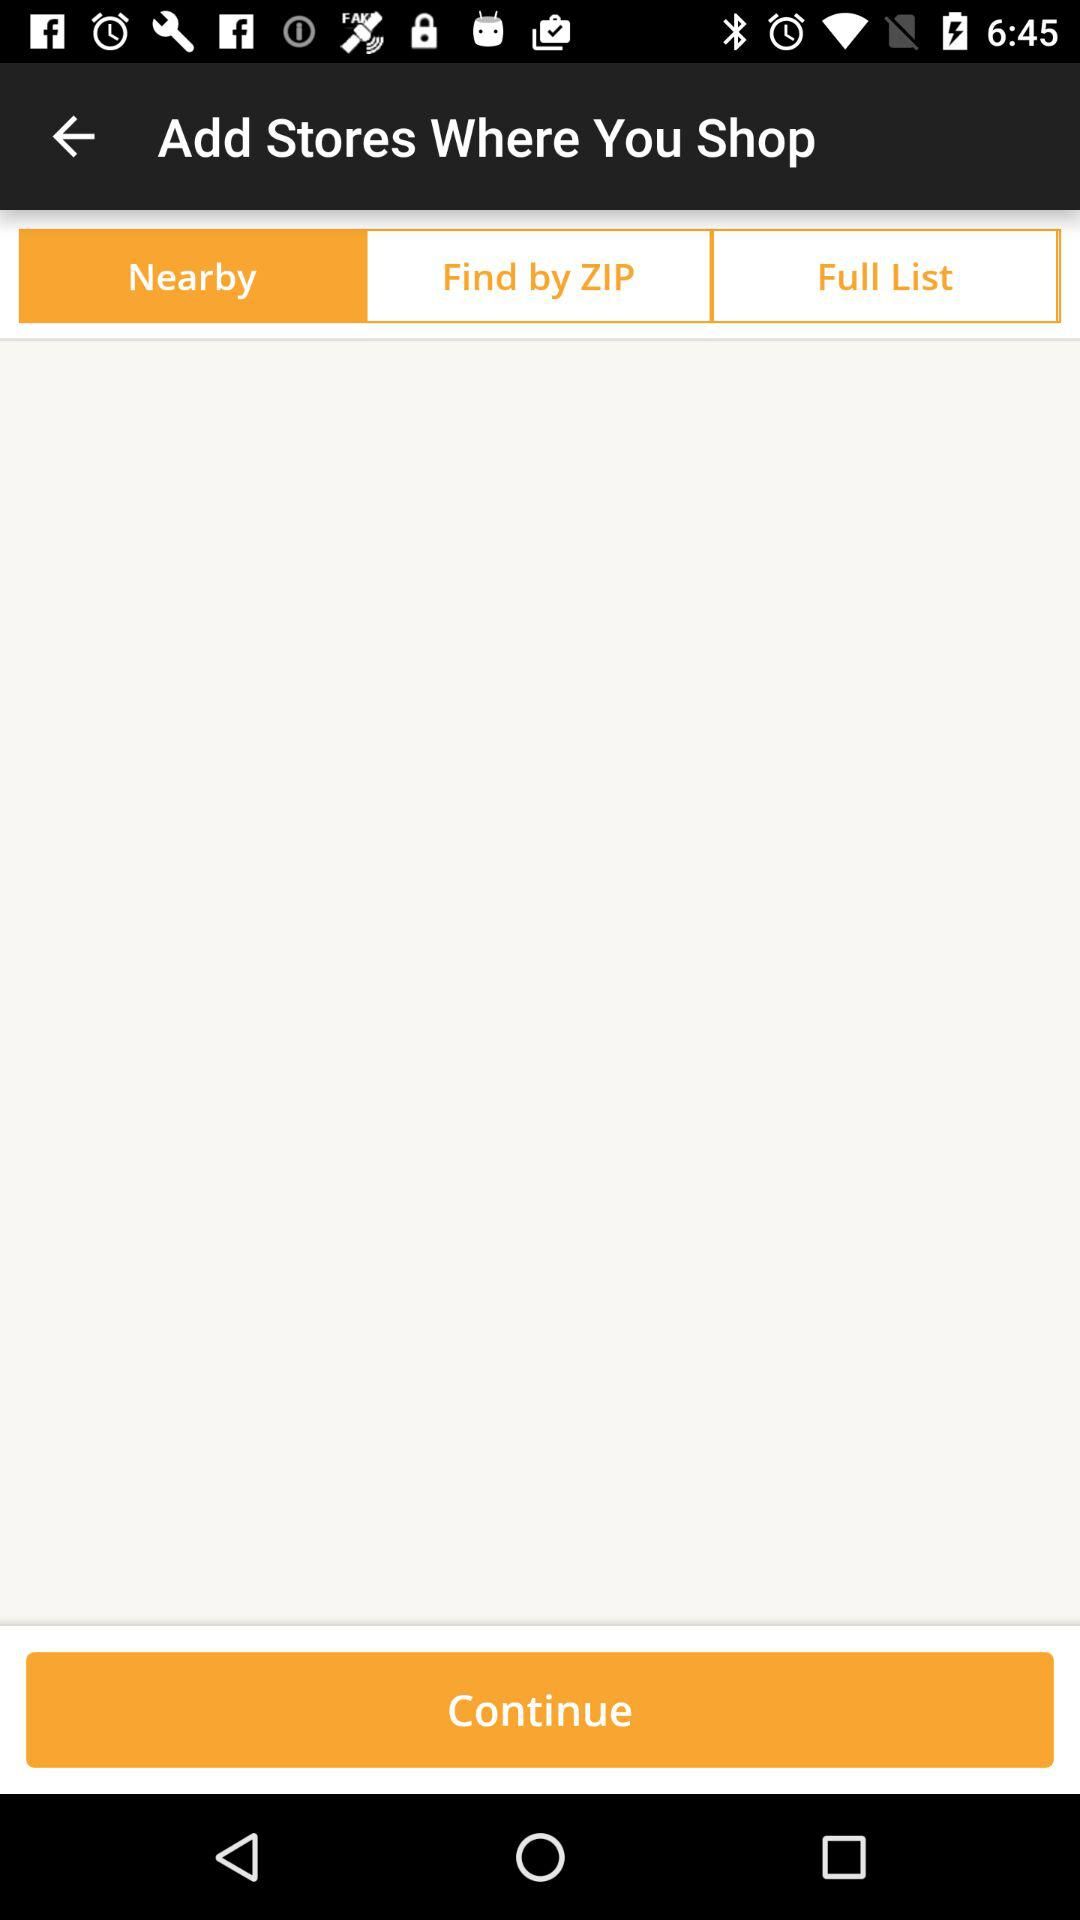Which option is selected? The selected option is "Nearby". 